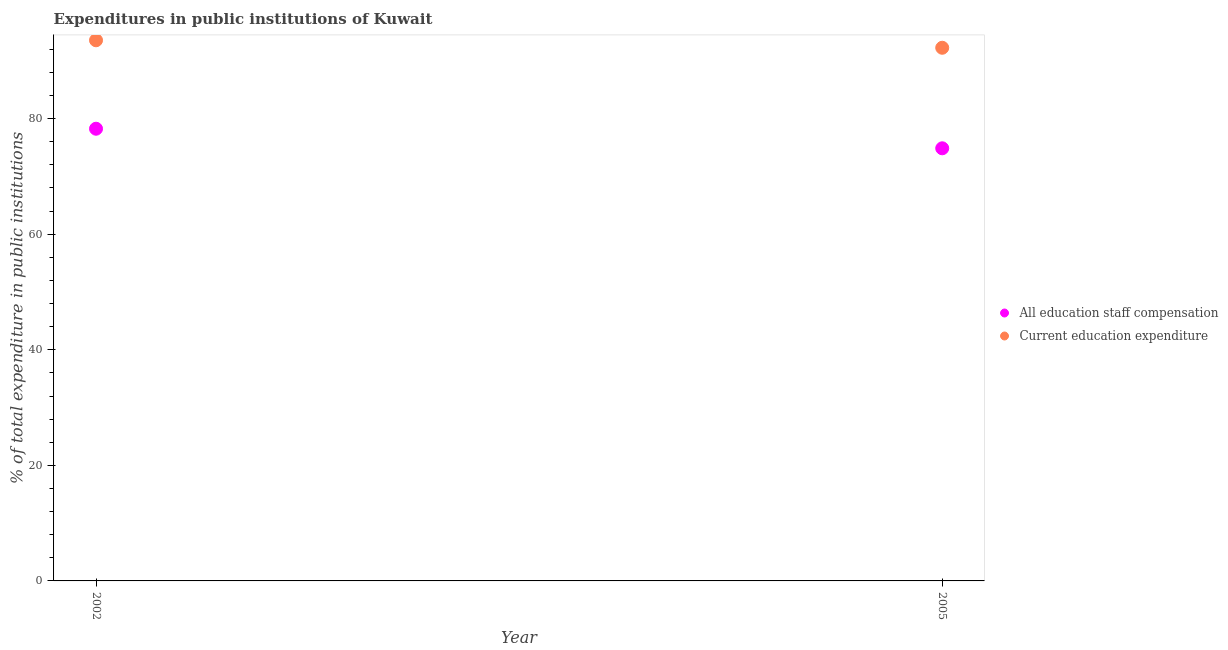What is the expenditure in education in 2005?
Give a very brief answer. 92.27. Across all years, what is the maximum expenditure in education?
Ensure brevity in your answer.  93.56. Across all years, what is the minimum expenditure in staff compensation?
Ensure brevity in your answer.  74.87. In which year was the expenditure in staff compensation maximum?
Provide a short and direct response. 2002. What is the total expenditure in education in the graph?
Offer a terse response. 185.83. What is the difference between the expenditure in education in 2002 and that in 2005?
Your answer should be very brief. 1.3. What is the difference between the expenditure in staff compensation in 2002 and the expenditure in education in 2005?
Ensure brevity in your answer.  -14.01. What is the average expenditure in education per year?
Your answer should be very brief. 92.91. In the year 2005, what is the difference between the expenditure in staff compensation and expenditure in education?
Provide a short and direct response. -17.4. In how many years, is the expenditure in education greater than 36 %?
Give a very brief answer. 2. What is the ratio of the expenditure in staff compensation in 2002 to that in 2005?
Ensure brevity in your answer.  1.05. Is the expenditure in education strictly greater than the expenditure in staff compensation over the years?
Keep it short and to the point. Yes. Is the expenditure in staff compensation strictly less than the expenditure in education over the years?
Your response must be concise. Yes. Are the values on the major ticks of Y-axis written in scientific E-notation?
Provide a short and direct response. No. Where does the legend appear in the graph?
Ensure brevity in your answer.  Center right. How are the legend labels stacked?
Ensure brevity in your answer.  Vertical. What is the title of the graph?
Your answer should be compact. Expenditures in public institutions of Kuwait. What is the label or title of the X-axis?
Provide a succinct answer. Year. What is the label or title of the Y-axis?
Offer a very short reply. % of total expenditure in public institutions. What is the % of total expenditure in public institutions of All education staff compensation in 2002?
Offer a very short reply. 78.25. What is the % of total expenditure in public institutions of Current education expenditure in 2002?
Provide a short and direct response. 93.56. What is the % of total expenditure in public institutions of All education staff compensation in 2005?
Give a very brief answer. 74.87. What is the % of total expenditure in public institutions in Current education expenditure in 2005?
Keep it short and to the point. 92.27. Across all years, what is the maximum % of total expenditure in public institutions in All education staff compensation?
Offer a very short reply. 78.25. Across all years, what is the maximum % of total expenditure in public institutions of Current education expenditure?
Make the answer very short. 93.56. Across all years, what is the minimum % of total expenditure in public institutions in All education staff compensation?
Your answer should be very brief. 74.87. Across all years, what is the minimum % of total expenditure in public institutions of Current education expenditure?
Offer a terse response. 92.27. What is the total % of total expenditure in public institutions of All education staff compensation in the graph?
Offer a terse response. 153.12. What is the total % of total expenditure in public institutions of Current education expenditure in the graph?
Offer a terse response. 185.83. What is the difference between the % of total expenditure in public institutions of All education staff compensation in 2002 and that in 2005?
Your response must be concise. 3.39. What is the difference between the % of total expenditure in public institutions of Current education expenditure in 2002 and that in 2005?
Provide a succinct answer. 1.3. What is the difference between the % of total expenditure in public institutions of All education staff compensation in 2002 and the % of total expenditure in public institutions of Current education expenditure in 2005?
Provide a succinct answer. -14.01. What is the average % of total expenditure in public institutions in All education staff compensation per year?
Offer a terse response. 76.56. What is the average % of total expenditure in public institutions in Current education expenditure per year?
Your answer should be very brief. 92.91. In the year 2002, what is the difference between the % of total expenditure in public institutions of All education staff compensation and % of total expenditure in public institutions of Current education expenditure?
Your answer should be very brief. -15.31. In the year 2005, what is the difference between the % of total expenditure in public institutions in All education staff compensation and % of total expenditure in public institutions in Current education expenditure?
Provide a short and direct response. -17.4. What is the ratio of the % of total expenditure in public institutions in All education staff compensation in 2002 to that in 2005?
Offer a very short reply. 1.05. What is the difference between the highest and the second highest % of total expenditure in public institutions of All education staff compensation?
Make the answer very short. 3.39. What is the difference between the highest and the second highest % of total expenditure in public institutions in Current education expenditure?
Offer a terse response. 1.3. What is the difference between the highest and the lowest % of total expenditure in public institutions of All education staff compensation?
Provide a short and direct response. 3.39. What is the difference between the highest and the lowest % of total expenditure in public institutions in Current education expenditure?
Provide a short and direct response. 1.3. 